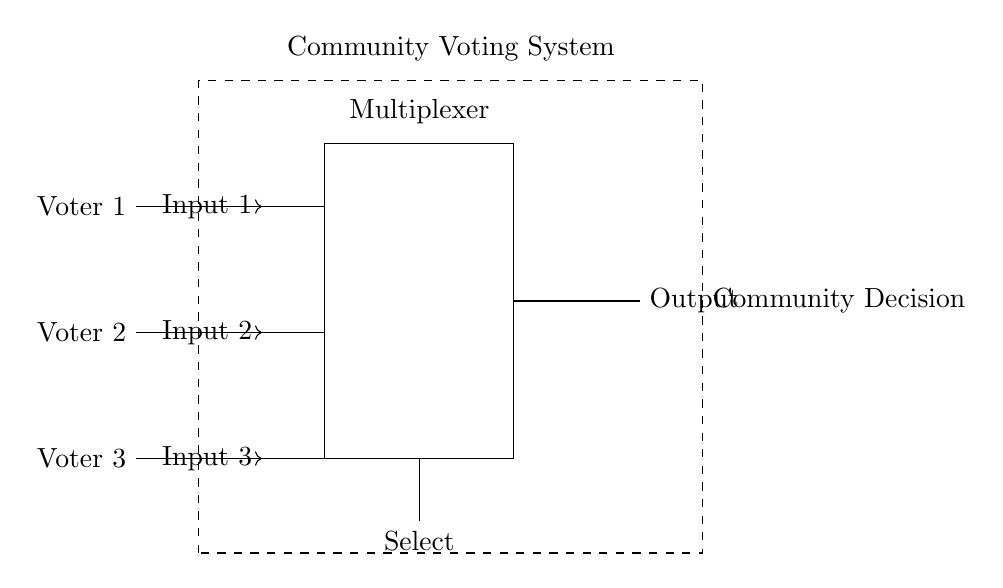What is the output of the multiplexer? The output is determined by the selected input line. In this case, the select input connects to one of the three voter inputs, meaning the output will match the state of the selected voter.
Answer: Output How many voter inputs are there? There are three voter inputs as represented by the connections to the left side of the multiplexer.
Answer: Three What does the dashed rectangle represent? The dashed rectangle encloses the entire community voting system, indicating the area where the voting process takes place including voters and the multiplexer.
Answer: Community Voting System What is the function of the select line? The select line is responsible for choosing which of the input lines (voter inputs) should be routed to the output. This line determines the active input.
Answer: Selecting input Who are the participants in the voting system? The participants are the voters, described as Voter 1, Voter 2, and Voter 3 on the left side of the circuit diagram, each providing input to the multiplexer.
Answer: Voter 1, Voter 2, Voter 3 What is indicated by the arrow connections from the voters? The arrows indicate the direction of signal flow from the voter inputs towards the multiplexer, signifying that their choices will be considered by the system.
Answer: Direction of signal flow What type of circuit is being described? The circuit is a digital multiplexer-based voting system used for community decision-making, which can handle inputs from multiple voters.
Answer: Digital voting system 